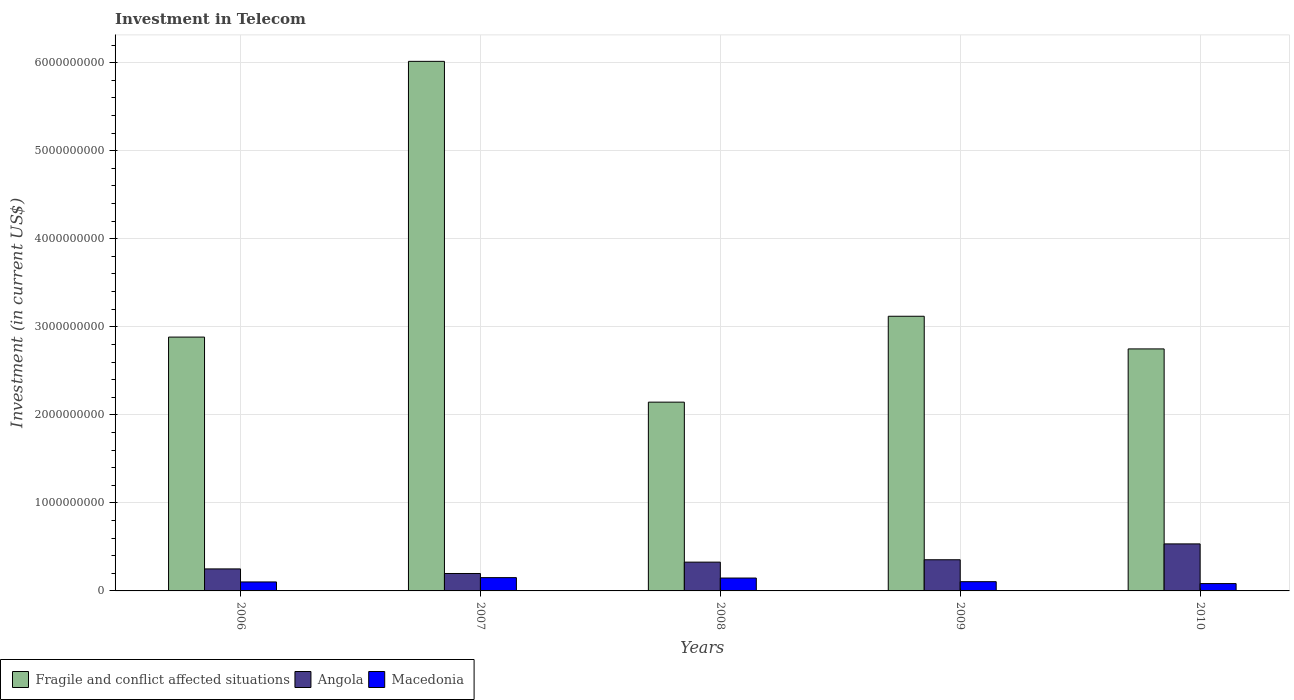How many groups of bars are there?
Ensure brevity in your answer.  5. Are the number of bars per tick equal to the number of legend labels?
Provide a succinct answer. Yes. How many bars are there on the 5th tick from the left?
Your response must be concise. 3. What is the label of the 5th group of bars from the left?
Your answer should be very brief. 2010. In how many cases, is the number of bars for a given year not equal to the number of legend labels?
Offer a terse response. 0. What is the amount invested in telecom in Angola in 2006?
Your response must be concise. 2.50e+08. Across all years, what is the maximum amount invested in telecom in Fragile and conflict affected situations?
Your answer should be compact. 6.01e+09. Across all years, what is the minimum amount invested in telecom in Macedonia?
Your answer should be compact. 8.33e+07. What is the total amount invested in telecom in Macedonia in the graph?
Your answer should be compact. 5.88e+08. What is the difference between the amount invested in telecom in Macedonia in 2007 and that in 2008?
Offer a very short reply. 4.70e+06. What is the difference between the amount invested in telecom in Angola in 2010 and the amount invested in telecom in Fragile and conflict affected situations in 2006?
Offer a very short reply. -2.35e+09. What is the average amount invested in telecom in Macedonia per year?
Your answer should be compact. 1.18e+08. In the year 2006, what is the difference between the amount invested in telecom in Macedonia and amount invested in telecom in Angola?
Keep it short and to the point. -1.48e+08. In how many years, is the amount invested in telecom in Macedonia greater than 5400000000 US$?
Offer a very short reply. 0. What is the ratio of the amount invested in telecom in Macedonia in 2009 to that in 2010?
Offer a very short reply. 1.26. Is the amount invested in telecom in Angola in 2007 less than that in 2010?
Give a very brief answer. Yes. Is the difference between the amount invested in telecom in Macedonia in 2009 and 2010 greater than the difference between the amount invested in telecom in Angola in 2009 and 2010?
Make the answer very short. Yes. What is the difference between the highest and the second highest amount invested in telecom in Fragile and conflict affected situations?
Provide a succinct answer. 2.90e+09. What is the difference between the highest and the lowest amount invested in telecom in Angola?
Provide a short and direct response. 3.36e+08. In how many years, is the amount invested in telecom in Macedonia greater than the average amount invested in telecom in Macedonia taken over all years?
Provide a short and direct response. 2. Is the sum of the amount invested in telecom in Angola in 2006 and 2010 greater than the maximum amount invested in telecom in Macedonia across all years?
Your answer should be very brief. Yes. What does the 3rd bar from the left in 2006 represents?
Offer a very short reply. Macedonia. What does the 1st bar from the right in 2009 represents?
Provide a short and direct response. Macedonia. How many bars are there?
Offer a very short reply. 15. Are all the bars in the graph horizontal?
Keep it short and to the point. No. Are the values on the major ticks of Y-axis written in scientific E-notation?
Offer a very short reply. No. Does the graph contain grids?
Your answer should be very brief. Yes. Where does the legend appear in the graph?
Ensure brevity in your answer.  Bottom left. How are the legend labels stacked?
Keep it short and to the point. Horizontal. What is the title of the graph?
Give a very brief answer. Investment in Telecom. Does "Middle income" appear as one of the legend labels in the graph?
Provide a short and direct response. No. What is the label or title of the X-axis?
Provide a short and direct response. Years. What is the label or title of the Y-axis?
Make the answer very short. Investment (in current US$). What is the Investment (in current US$) of Fragile and conflict affected situations in 2006?
Offer a very short reply. 2.88e+09. What is the Investment (in current US$) of Angola in 2006?
Give a very brief answer. 2.50e+08. What is the Investment (in current US$) of Macedonia in 2006?
Ensure brevity in your answer.  1.02e+08. What is the Investment (in current US$) in Fragile and conflict affected situations in 2007?
Your answer should be very brief. 6.01e+09. What is the Investment (in current US$) in Angola in 2007?
Your answer should be very brief. 1.98e+08. What is the Investment (in current US$) of Macedonia in 2007?
Offer a terse response. 1.51e+08. What is the Investment (in current US$) in Fragile and conflict affected situations in 2008?
Your answer should be very brief. 2.14e+09. What is the Investment (in current US$) of Angola in 2008?
Keep it short and to the point. 3.27e+08. What is the Investment (in current US$) of Macedonia in 2008?
Your answer should be compact. 1.46e+08. What is the Investment (in current US$) of Fragile and conflict affected situations in 2009?
Give a very brief answer. 3.12e+09. What is the Investment (in current US$) in Angola in 2009?
Ensure brevity in your answer.  3.54e+08. What is the Investment (in current US$) of Macedonia in 2009?
Ensure brevity in your answer.  1.05e+08. What is the Investment (in current US$) of Fragile and conflict affected situations in 2010?
Give a very brief answer. 2.75e+09. What is the Investment (in current US$) of Angola in 2010?
Your answer should be very brief. 5.34e+08. What is the Investment (in current US$) in Macedonia in 2010?
Keep it short and to the point. 8.33e+07. Across all years, what is the maximum Investment (in current US$) of Fragile and conflict affected situations?
Give a very brief answer. 6.01e+09. Across all years, what is the maximum Investment (in current US$) in Angola?
Provide a short and direct response. 5.34e+08. Across all years, what is the maximum Investment (in current US$) of Macedonia?
Ensure brevity in your answer.  1.51e+08. Across all years, what is the minimum Investment (in current US$) of Fragile and conflict affected situations?
Give a very brief answer. 2.14e+09. Across all years, what is the minimum Investment (in current US$) of Angola?
Provide a succinct answer. 1.98e+08. Across all years, what is the minimum Investment (in current US$) of Macedonia?
Your response must be concise. 8.33e+07. What is the total Investment (in current US$) of Fragile and conflict affected situations in the graph?
Offer a very short reply. 1.69e+1. What is the total Investment (in current US$) of Angola in the graph?
Offer a very short reply. 1.66e+09. What is the total Investment (in current US$) of Macedonia in the graph?
Give a very brief answer. 5.88e+08. What is the difference between the Investment (in current US$) of Fragile and conflict affected situations in 2006 and that in 2007?
Your response must be concise. -3.13e+09. What is the difference between the Investment (in current US$) of Angola in 2006 and that in 2007?
Your answer should be very brief. 5.20e+07. What is the difference between the Investment (in current US$) in Macedonia in 2006 and that in 2007?
Provide a succinct answer. -4.90e+07. What is the difference between the Investment (in current US$) of Fragile and conflict affected situations in 2006 and that in 2008?
Offer a terse response. 7.39e+08. What is the difference between the Investment (in current US$) of Angola in 2006 and that in 2008?
Offer a terse response. -7.70e+07. What is the difference between the Investment (in current US$) in Macedonia in 2006 and that in 2008?
Give a very brief answer. -4.43e+07. What is the difference between the Investment (in current US$) in Fragile and conflict affected situations in 2006 and that in 2009?
Your response must be concise. -2.37e+08. What is the difference between the Investment (in current US$) of Angola in 2006 and that in 2009?
Provide a succinct answer. -1.04e+08. What is the difference between the Investment (in current US$) of Macedonia in 2006 and that in 2009?
Your response must be concise. -3.00e+06. What is the difference between the Investment (in current US$) in Fragile and conflict affected situations in 2006 and that in 2010?
Make the answer very short. 1.34e+08. What is the difference between the Investment (in current US$) in Angola in 2006 and that in 2010?
Provide a short and direct response. -2.84e+08. What is the difference between the Investment (in current US$) in Macedonia in 2006 and that in 2010?
Your response must be concise. 1.87e+07. What is the difference between the Investment (in current US$) in Fragile and conflict affected situations in 2007 and that in 2008?
Offer a terse response. 3.87e+09. What is the difference between the Investment (in current US$) in Angola in 2007 and that in 2008?
Provide a succinct answer. -1.29e+08. What is the difference between the Investment (in current US$) in Macedonia in 2007 and that in 2008?
Your answer should be very brief. 4.70e+06. What is the difference between the Investment (in current US$) of Fragile and conflict affected situations in 2007 and that in 2009?
Your response must be concise. 2.90e+09. What is the difference between the Investment (in current US$) in Angola in 2007 and that in 2009?
Make the answer very short. -1.56e+08. What is the difference between the Investment (in current US$) of Macedonia in 2007 and that in 2009?
Keep it short and to the point. 4.60e+07. What is the difference between the Investment (in current US$) of Fragile and conflict affected situations in 2007 and that in 2010?
Ensure brevity in your answer.  3.27e+09. What is the difference between the Investment (in current US$) of Angola in 2007 and that in 2010?
Provide a succinct answer. -3.36e+08. What is the difference between the Investment (in current US$) in Macedonia in 2007 and that in 2010?
Provide a succinct answer. 6.77e+07. What is the difference between the Investment (in current US$) in Fragile and conflict affected situations in 2008 and that in 2009?
Make the answer very short. -9.76e+08. What is the difference between the Investment (in current US$) in Angola in 2008 and that in 2009?
Provide a short and direct response. -2.70e+07. What is the difference between the Investment (in current US$) of Macedonia in 2008 and that in 2009?
Make the answer very short. 4.13e+07. What is the difference between the Investment (in current US$) in Fragile and conflict affected situations in 2008 and that in 2010?
Offer a very short reply. -6.05e+08. What is the difference between the Investment (in current US$) of Angola in 2008 and that in 2010?
Ensure brevity in your answer.  -2.07e+08. What is the difference between the Investment (in current US$) in Macedonia in 2008 and that in 2010?
Your answer should be very brief. 6.30e+07. What is the difference between the Investment (in current US$) in Fragile and conflict affected situations in 2009 and that in 2010?
Your response must be concise. 3.71e+08. What is the difference between the Investment (in current US$) of Angola in 2009 and that in 2010?
Give a very brief answer. -1.80e+08. What is the difference between the Investment (in current US$) of Macedonia in 2009 and that in 2010?
Your answer should be compact. 2.17e+07. What is the difference between the Investment (in current US$) of Fragile and conflict affected situations in 2006 and the Investment (in current US$) of Angola in 2007?
Your response must be concise. 2.68e+09. What is the difference between the Investment (in current US$) of Fragile and conflict affected situations in 2006 and the Investment (in current US$) of Macedonia in 2007?
Ensure brevity in your answer.  2.73e+09. What is the difference between the Investment (in current US$) of Angola in 2006 and the Investment (in current US$) of Macedonia in 2007?
Your answer should be very brief. 9.90e+07. What is the difference between the Investment (in current US$) in Fragile and conflict affected situations in 2006 and the Investment (in current US$) in Angola in 2008?
Your answer should be very brief. 2.56e+09. What is the difference between the Investment (in current US$) in Fragile and conflict affected situations in 2006 and the Investment (in current US$) in Macedonia in 2008?
Make the answer very short. 2.74e+09. What is the difference between the Investment (in current US$) in Angola in 2006 and the Investment (in current US$) in Macedonia in 2008?
Keep it short and to the point. 1.04e+08. What is the difference between the Investment (in current US$) of Fragile and conflict affected situations in 2006 and the Investment (in current US$) of Angola in 2009?
Your answer should be very brief. 2.53e+09. What is the difference between the Investment (in current US$) in Fragile and conflict affected situations in 2006 and the Investment (in current US$) in Macedonia in 2009?
Your response must be concise. 2.78e+09. What is the difference between the Investment (in current US$) in Angola in 2006 and the Investment (in current US$) in Macedonia in 2009?
Ensure brevity in your answer.  1.45e+08. What is the difference between the Investment (in current US$) in Fragile and conflict affected situations in 2006 and the Investment (in current US$) in Angola in 2010?
Give a very brief answer. 2.35e+09. What is the difference between the Investment (in current US$) of Fragile and conflict affected situations in 2006 and the Investment (in current US$) of Macedonia in 2010?
Offer a very short reply. 2.80e+09. What is the difference between the Investment (in current US$) of Angola in 2006 and the Investment (in current US$) of Macedonia in 2010?
Provide a short and direct response. 1.67e+08. What is the difference between the Investment (in current US$) in Fragile and conflict affected situations in 2007 and the Investment (in current US$) in Angola in 2008?
Provide a succinct answer. 5.69e+09. What is the difference between the Investment (in current US$) of Fragile and conflict affected situations in 2007 and the Investment (in current US$) of Macedonia in 2008?
Provide a succinct answer. 5.87e+09. What is the difference between the Investment (in current US$) in Angola in 2007 and the Investment (in current US$) in Macedonia in 2008?
Offer a terse response. 5.17e+07. What is the difference between the Investment (in current US$) in Fragile and conflict affected situations in 2007 and the Investment (in current US$) in Angola in 2009?
Your response must be concise. 5.66e+09. What is the difference between the Investment (in current US$) of Fragile and conflict affected situations in 2007 and the Investment (in current US$) of Macedonia in 2009?
Provide a succinct answer. 5.91e+09. What is the difference between the Investment (in current US$) of Angola in 2007 and the Investment (in current US$) of Macedonia in 2009?
Your answer should be very brief. 9.30e+07. What is the difference between the Investment (in current US$) of Fragile and conflict affected situations in 2007 and the Investment (in current US$) of Angola in 2010?
Your response must be concise. 5.48e+09. What is the difference between the Investment (in current US$) in Fragile and conflict affected situations in 2007 and the Investment (in current US$) in Macedonia in 2010?
Give a very brief answer. 5.93e+09. What is the difference between the Investment (in current US$) in Angola in 2007 and the Investment (in current US$) in Macedonia in 2010?
Make the answer very short. 1.15e+08. What is the difference between the Investment (in current US$) in Fragile and conflict affected situations in 2008 and the Investment (in current US$) in Angola in 2009?
Offer a very short reply. 1.79e+09. What is the difference between the Investment (in current US$) of Fragile and conflict affected situations in 2008 and the Investment (in current US$) of Macedonia in 2009?
Provide a short and direct response. 2.04e+09. What is the difference between the Investment (in current US$) of Angola in 2008 and the Investment (in current US$) of Macedonia in 2009?
Offer a terse response. 2.22e+08. What is the difference between the Investment (in current US$) in Fragile and conflict affected situations in 2008 and the Investment (in current US$) in Angola in 2010?
Offer a terse response. 1.61e+09. What is the difference between the Investment (in current US$) of Fragile and conflict affected situations in 2008 and the Investment (in current US$) of Macedonia in 2010?
Ensure brevity in your answer.  2.06e+09. What is the difference between the Investment (in current US$) in Angola in 2008 and the Investment (in current US$) in Macedonia in 2010?
Offer a terse response. 2.44e+08. What is the difference between the Investment (in current US$) in Fragile and conflict affected situations in 2009 and the Investment (in current US$) in Angola in 2010?
Offer a terse response. 2.59e+09. What is the difference between the Investment (in current US$) in Fragile and conflict affected situations in 2009 and the Investment (in current US$) in Macedonia in 2010?
Your response must be concise. 3.04e+09. What is the difference between the Investment (in current US$) of Angola in 2009 and the Investment (in current US$) of Macedonia in 2010?
Offer a terse response. 2.71e+08. What is the average Investment (in current US$) of Fragile and conflict affected situations per year?
Your response must be concise. 3.38e+09. What is the average Investment (in current US$) of Angola per year?
Your response must be concise. 3.33e+08. What is the average Investment (in current US$) of Macedonia per year?
Offer a terse response. 1.18e+08. In the year 2006, what is the difference between the Investment (in current US$) of Fragile and conflict affected situations and Investment (in current US$) of Angola?
Keep it short and to the point. 2.63e+09. In the year 2006, what is the difference between the Investment (in current US$) of Fragile and conflict affected situations and Investment (in current US$) of Macedonia?
Your answer should be compact. 2.78e+09. In the year 2006, what is the difference between the Investment (in current US$) in Angola and Investment (in current US$) in Macedonia?
Give a very brief answer. 1.48e+08. In the year 2007, what is the difference between the Investment (in current US$) in Fragile and conflict affected situations and Investment (in current US$) in Angola?
Give a very brief answer. 5.82e+09. In the year 2007, what is the difference between the Investment (in current US$) in Fragile and conflict affected situations and Investment (in current US$) in Macedonia?
Give a very brief answer. 5.86e+09. In the year 2007, what is the difference between the Investment (in current US$) in Angola and Investment (in current US$) in Macedonia?
Keep it short and to the point. 4.70e+07. In the year 2008, what is the difference between the Investment (in current US$) of Fragile and conflict affected situations and Investment (in current US$) of Angola?
Provide a short and direct response. 1.82e+09. In the year 2008, what is the difference between the Investment (in current US$) in Fragile and conflict affected situations and Investment (in current US$) in Macedonia?
Provide a succinct answer. 2.00e+09. In the year 2008, what is the difference between the Investment (in current US$) of Angola and Investment (in current US$) of Macedonia?
Your answer should be very brief. 1.81e+08. In the year 2009, what is the difference between the Investment (in current US$) of Fragile and conflict affected situations and Investment (in current US$) of Angola?
Your response must be concise. 2.77e+09. In the year 2009, what is the difference between the Investment (in current US$) in Fragile and conflict affected situations and Investment (in current US$) in Macedonia?
Give a very brief answer. 3.01e+09. In the year 2009, what is the difference between the Investment (in current US$) in Angola and Investment (in current US$) in Macedonia?
Give a very brief answer. 2.49e+08. In the year 2010, what is the difference between the Investment (in current US$) of Fragile and conflict affected situations and Investment (in current US$) of Angola?
Ensure brevity in your answer.  2.21e+09. In the year 2010, what is the difference between the Investment (in current US$) in Fragile and conflict affected situations and Investment (in current US$) in Macedonia?
Provide a succinct answer. 2.67e+09. In the year 2010, what is the difference between the Investment (in current US$) of Angola and Investment (in current US$) of Macedonia?
Ensure brevity in your answer.  4.51e+08. What is the ratio of the Investment (in current US$) in Fragile and conflict affected situations in 2006 to that in 2007?
Your answer should be very brief. 0.48. What is the ratio of the Investment (in current US$) in Angola in 2006 to that in 2007?
Ensure brevity in your answer.  1.26. What is the ratio of the Investment (in current US$) of Macedonia in 2006 to that in 2007?
Provide a succinct answer. 0.68. What is the ratio of the Investment (in current US$) in Fragile and conflict affected situations in 2006 to that in 2008?
Your answer should be compact. 1.34. What is the ratio of the Investment (in current US$) in Angola in 2006 to that in 2008?
Your response must be concise. 0.76. What is the ratio of the Investment (in current US$) in Macedonia in 2006 to that in 2008?
Offer a terse response. 0.7. What is the ratio of the Investment (in current US$) in Fragile and conflict affected situations in 2006 to that in 2009?
Your response must be concise. 0.92. What is the ratio of the Investment (in current US$) of Angola in 2006 to that in 2009?
Provide a succinct answer. 0.71. What is the ratio of the Investment (in current US$) in Macedonia in 2006 to that in 2009?
Your answer should be compact. 0.97. What is the ratio of the Investment (in current US$) of Fragile and conflict affected situations in 2006 to that in 2010?
Offer a very short reply. 1.05. What is the ratio of the Investment (in current US$) in Angola in 2006 to that in 2010?
Your response must be concise. 0.47. What is the ratio of the Investment (in current US$) in Macedonia in 2006 to that in 2010?
Your answer should be very brief. 1.22. What is the ratio of the Investment (in current US$) in Fragile and conflict affected situations in 2007 to that in 2008?
Your answer should be very brief. 2.81. What is the ratio of the Investment (in current US$) in Angola in 2007 to that in 2008?
Provide a succinct answer. 0.61. What is the ratio of the Investment (in current US$) in Macedonia in 2007 to that in 2008?
Give a very brief answer. 1.03. What is the ratio of the Investment (in current US$) of Fragile and conflict affected situations in 2007 to that in 2009?
Provide a succinct answer. 1.93. What is the ratio of the Investment (in current US$) in Angola in 2007 to that in 2009?
Offer a terse response. 0.56. What is the ratio of the Investment (in current US$) in Macedonia in 2007 to that in 2009?
Make the answer very short. 1.44. What is the ratio of the Investment (in current US$) of Fragile and conflict affected situations in 2007 to that in 2010?
Make the answer very short. 2.19. What is the ratio of the Investment (in current US$) of Angola in 2007 to that in 2010?
Your answer should be very brief. 0.37. What is the ratio of the Investment (in current US$) of Macedonia in 2007 to that in 2010?
Keep it short and to the point. 1.81. What is the ratio of the Investment (in current US$) in Fragile and conflict affected situations in 2008 to that in 2009?
Offer a terse response. 0.69. What is the ratio of the Investment (in current US$) in Angola in 2008 to that in 2009?
Keep it short and to the point. 0.92. What is the ratio of the Investment (in current US$) of Macedonia in 2008 to that in 2009?
Your answer should be compact. 1.39. What is the ratio of the Investment (in current US$) of Fragile and conflict affected situations in 2008 to that in 2010?
Keep it short and to the point. 0.78. What is the ratio of the Investment (in current US$) in Angola in 2008 to that in 2010?
Provide a succinct answer. 0.61. What is the ratio of the Investment (in current US$) of Macedonia in 2008 to that in 2010?
Your answer should be very brief. 1.76. What is the ratio of the Investment (in current US$) of Fragile and conflict affected situations in 2009 to that in 2010?
Your answer should be very brief. 1.13. What is the ratio of the Investment (in current US$) in Angola in 2009 to that in 2010?
Give a very brief answer. 0.66. What is the ratio of the Investment (in current US$) of Macedonia in 2009 to that in 2010?
Provide a succinct answer. 1.26. What is the difference between the highest and the second highest Investment (in current US$) of Fragile and conflict affected situations?
Your answer should be compact. 2.90e+09. What is the difference between the highest and the second highest Investment (in current US$) of Angola?
Offer a very short reply. 1.80e+08. What is the difference between the highest and the second highest Investment (in current US$) in Macedonia?
Give a very brief answer. 4.70e+06. What is the difference between the highest and the lowest Investment (in current US$) in Fragile and conflict affected situations?
Your answer should be very brief. 3.87e+09. What is the difference between the highest and the lowest Investment (in current US$) in Angola?
Ensure brevity in your answer.  3.36e+08. What is the difference between the highest and the lowest Investment (in current US$) in Macedonia?
Your answer should be compact. 6.77e+07. 